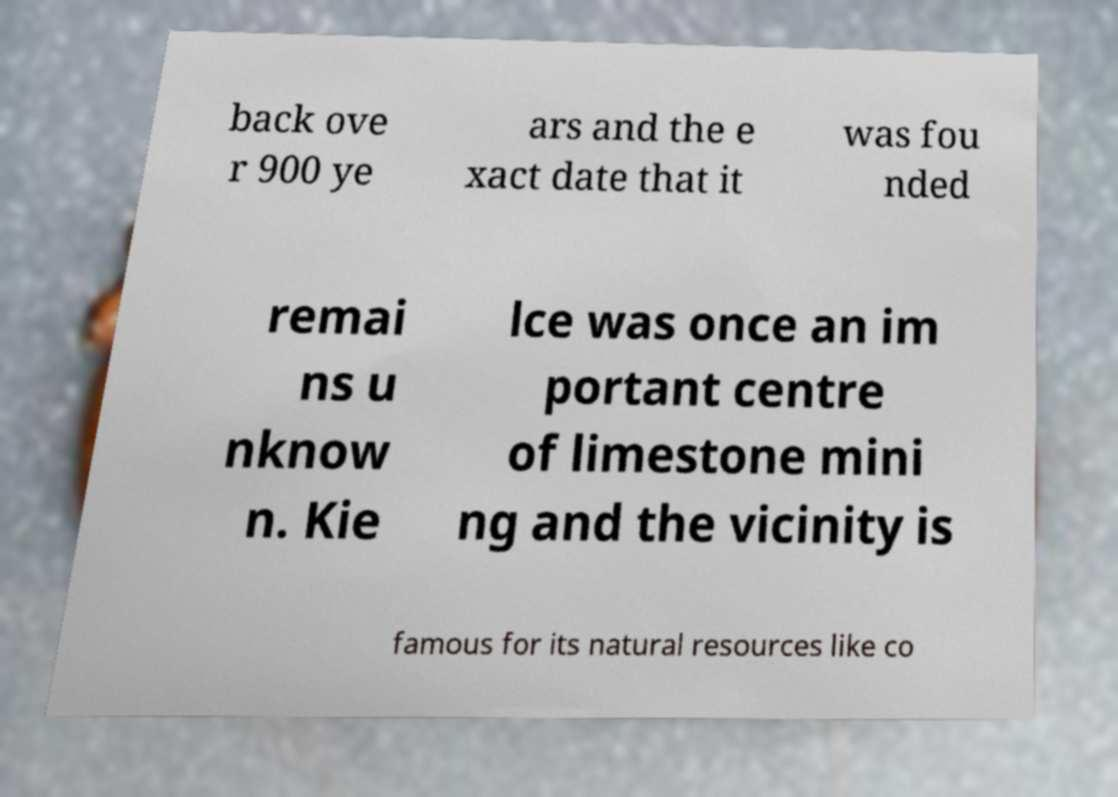There's text embedded in this image that I need extracted. Can you transcribe it verbatim? back ove r 900 ye ars and the e xact date that it was fou nded remai ns u nknow n. Kie lce was once an im portant centre of limestone mini ng and the vicinity is famous for its natural resources like co 